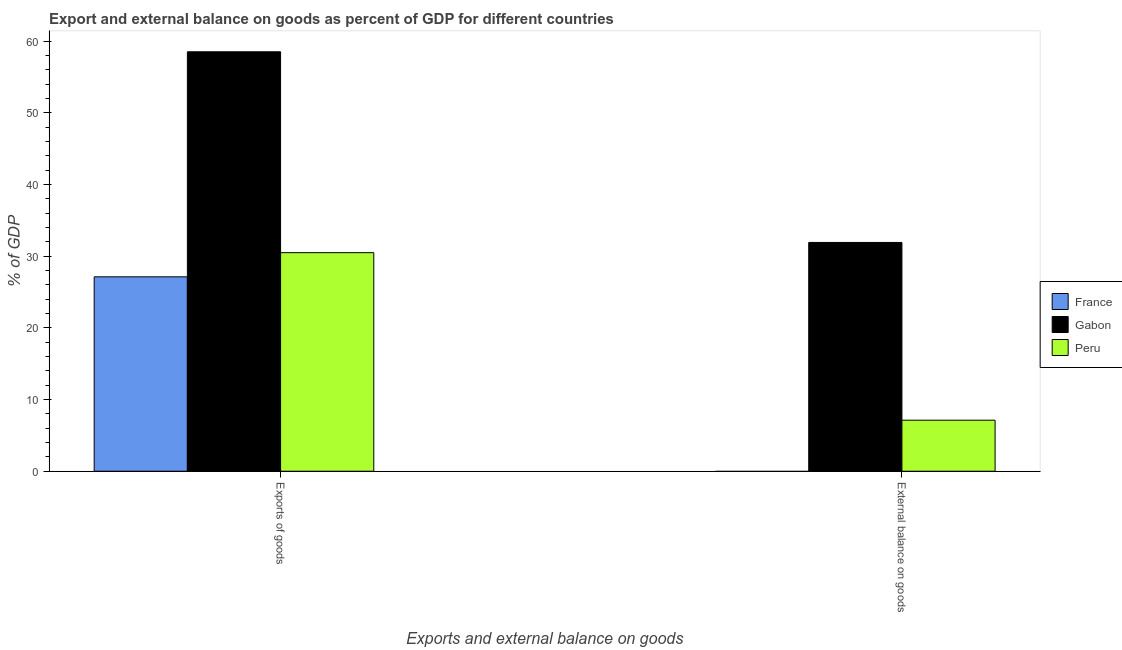How many groups of bars are there?
Ensure brevity in your answer.  2. Are the number of bars per tick equal to the number of legend labels?
Keep it short and to the point. No. Are the number of bars on each tick of the X-axis equal?
Your answer should be compact. No. How many bars are there on the 1st tick from the left?
Provide a succinct answer. 3. What is the label of the 2nd group of bars from the left?
Give a very brief answer. External balance on goods. What is the external balance on goods as percentage of gdp in France?
Provide a short and direct response. 0. Across all countries, what is the maximum export of goods as percentage of gdp?
Your response must be concise. 58.53. Across all countries, what is the minimum external balance on goods as percentage of gdp?
Give a very brief answer. 0. In which country was the export of goods as percentage of gdp maximum?
Make the answer very short. Gabon. What is the total export of goods as percentage of gdp in the graph?
Provide a short and direct response. 116.16. What is the difference between the external balance on goods as percentage of gdp in Gabon and that in Peru?
Provide a short and direct response. 24.8. What is the difference between the export of goods as percentage of gdp in Peru and the external balance on goods as percentage of gdp in Gabon?
Make the answer very short. -1.43. What is the average export of goods as percentage of gdp per country?
Your answer should be very brief. 38.72. What is the difference between the export of goods as percentage of gdp and external balance on goods as percentage of gdp in Gabon?
Make the answer very short. 26.6. In how many countries, is the external balance on goods as percentage of gdp greater than 20 %?
Make the answer very short. 1. What is the ratio of the export of goods as percentage of gdp in Peru to that in Gabon?
Ensure brevity in your answer.  0.52. How many bars are there?
Your answer should be compact. 5. Are all the bars in the graph horizontal?
Your answer should be compact. No. How many countries are there in the graph?
Your response must be concise. 3. Where does the legend appear in the graph?
Give a very brief answer. Center right. How many legend labels are there?
Your answer should be very brief. 3. How are the legend labels stacked?
Provide a succinct answer. Vertical. What is the title of the graph?
Give a very brief answer. Export and external balance on goods as percent of GDP for different countries. What is the label or title of the X-axis?
Keep it short and to the point. Exports and external balance on goods. What is the label or title of the Y-axis?
Make the answer very short. % of GDP. What is the % of GDP of France in Exports of goods?
Ensure brevity in your answer.  27.13. What is the % of GDP of Gabon in Exports of goods?
Offer a very short reply. 58.53. What is the % of GDP of Peru in Exports of goods?
Ensure brevity in your answer.  30.5. What is the % of GDP in Gabon in External balance on goods?
Provide a short and direct response. 31.92. What is the % of GDP of Peru in External balance on goods?
Give a very brief answer. 7.12. Across all Exports and external balance on goods, what is the maximum % of GDP in France?
Offer a terse response. 27.13. Across all Exports and external balance on goods, what is the maximum % of GDP in Gabon?
Give a very brief answer. 58.53. Across all Exports and external balance on goods, what is the maximum % of GDP of Peru?
Make the answer very short. 30.5. Across all Exports and external balance on goods, what is the minimum % of GDP in France?
Make the answer very short. 0. Across all Exports and external balance on goods, what is the minimum % of GDP of Gabon?
Your answer should be compact. 31.92. Across all Exports and external balance on goods, what is the minimum % of GDP in Peru?
Provide a short and direct response. 7.12. What is the total % of GDP of France in the graph?
Offer a very short reply. 27.13. What is the total % of GDP in Gabon in the graph?
Give a very brief answer. 90.45. What is the total % of GDP in Peru in the graph?
Offer a very short reply. 37.62. What is the difference between the % of GDP of Gabon in Exports of goods and that in External balance on goods?
Provide a succinct answer. 26.6. What is the difference between the % of GDP of Peru in Exports of goods and that in External balance on goods?
Ensure brevity in your answer.  23.38. What is the difference between the % of GDP of France in Exports of goods and the % of GDP of Gabon in External balance on goods?
Provide a succinct answer. -4.8. What is the difference between the % of GDP in France in Exports of goods and the % of GDP in Peru in External balance on goods?
Your response must be concise. 20.01. What is the difference between the % of GDP in Gabon in Exports of goods and the % of GDP in Peru in External balance on goods?
Offer a terse response. 51.41. What is the average % of GDP of France per Exports and external balance on goods?
Offer a very short reply. 13.56. What is the average % of GDP of Gabon per Exports and external balance on goods?
Keep it short and to the point. 45.23. What is the average % of GDP in Peru per Exports and external balance on goods?
Offer a very short reply. 18.81. What is the difference between the % of GDP of France and % of GDP of Gabon in Exports of goods?
Make the answer very short. -31.4. What is the difference between the % of GDP of France and % of GDP of Peru in Exports of goods?
Provide a succinct answer. -3.37. What is the difference between the % of GDP in Gabon and % of GDP in Peru in Exports of goods?
Provide a short and direct response. 28.03. What is the difference between the % of GDP in Gabon and % of GDP in Peru in External balance on goods?
Make the answer very short. 24.8. What is the ratio of the % of GDP of Gabon in Exports of goods to that in External balance on goods?
Offer a terse response. 1.83. What is the ratio of the % of GDP in Peru in Exports of goods to that in External balance on goods?
Provide a succinct answer. 4.28. What is the difference between the highest and the second highest % of GDP of Gabon?
Your response must be concise. 26.6. What is the difference between the highest and the second highest % of GDP of Peru?
Ensure brevity in your answer.  23.38. What is the difference between the highest and the lowest % of GDP in France?
Make the answer very short. 27.13. What is the difference between the highest and the lowest % of GDP of Gabon?
Your answer should be compact. 26.6. What is the difference between the highest and the lowest % of GDP in Peru?
Provide a short and direct response. 23.38. 